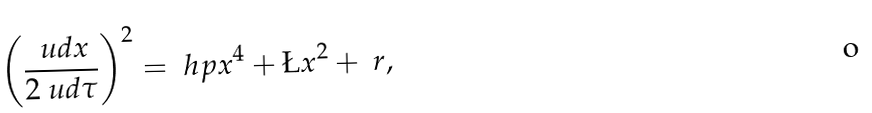<formula> <loc_0><loc_0><loc_500><loc_500>\left ( \frac { \ u d x } { 2 \ u d \tau } \right ) ^ { 2 } = \ h p x ^ { 4 } + \L x ^ { 2 } + \ r ,</formula> 